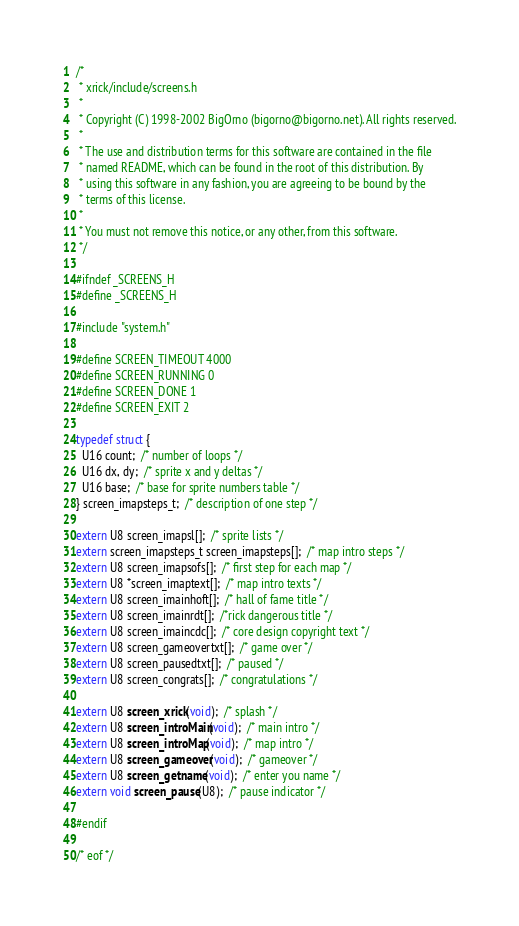<code> <loc_0><loc_0><loc_500><loc_500><_C_>/*
 * xrick/include/screens.h
 *
 * Copyright (C) 1998-2002 BigOrno (bigorno@bigorno.net). All rights reserved.
 *
 * The use and distribution terms for this software are contained in the file
 * named README, which can be found in the root of this distribution. By
 * using this software in any fashion, you are agreeing to be bound by the
 * terms of this license.
 *
 * You must not remove this notice, or any other, from this software.
 */

#ifndef _SCREENS_H
#define _SCREENS_H

#include "system.h"

#define SCREEN_TIMEOUT 4000
#define SCREEN_RUNNING 0
#define SCREEN_DONE 1
#define SCREEN_EXIT 2

typedef struct {
  U16 count;  /* number of loops */
  U16 dx, dy;  /* sprite x and y deltas */
  U16 base;  /* base for sprite numbers table */
} screen_imapsteps_t;  /* description of one step */

extern U8 screen_imapsl[];  /* sprite lists */
extern screen_imapsteps_t screen_imapsteps[];  /* map intro steps */
extern U8 screen_imapsofs[];  /* first step for each map */
extern U8 *screen_imaptext[];  /* map intro texts */
extern U8 screen_imainhoft[];  /* hall of fame title */
extern U8 screen_imainrdt[];  /*rick dangerous title */
extern U8 screen_imaincdc[];  /* core design copyright text */
extern U8 screen_gameovertxt[];  /* game over */
extern U8 screen_pausedtxt[];  /* paused */
extern U8 screen_congrats[];  /* congratulations */

extern U8 screen_xrick(void);  /* splash */
extern U8 screen_introMain(void);  /* main intro */
extern U8 screen_introMap(void);  /* map intro */
extern U8 screen_gameover(void);  /* gameover */
extern U8 screen_getname(void);  /* enter you name */
extern void screen_pause(U8);  /* pause indicator */

#endif

/* eof */
</code> 